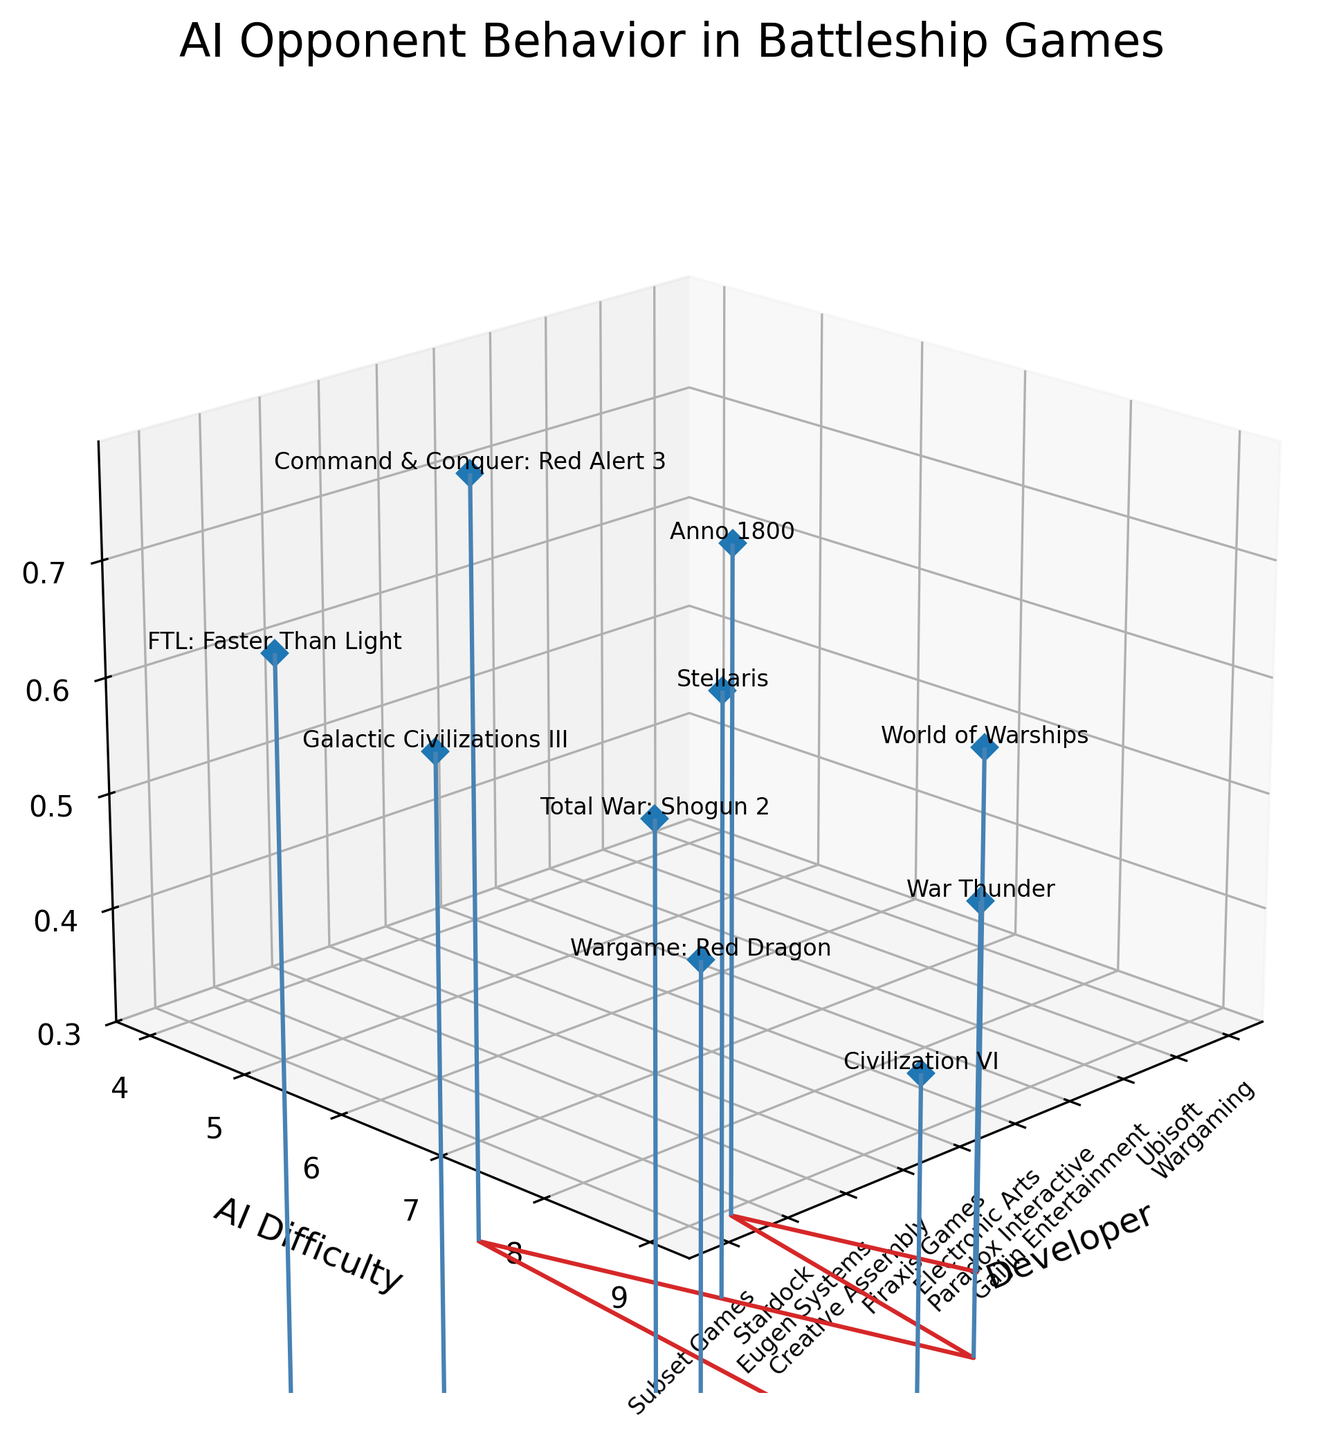What is the AI difficulty level for "War Thunder"? Look at the y-coordinate (AI Difficulty) for the "War Thunder" data point.
Answer: 8 Which game developed by "Ubisoft" has the highest player win rate? Locate the game by "Ubisoft" and look at its z-coordinate (Player Win Rate). There is only one game from Ubisoft, "Anno 1800".
Answer: Anno 1800 What's the range of AI difficulty levels shown in the plot? Identify the minimum and maximum values on the y-axis labeled "AI Difficulty".
Answer: 4-9 How many developers have player win rates less than 0.5 in their games? Count the number of data points where the z-coordinate (Player Win Rate) is less than 0.5.
Answer: 3 Which game has the lowest player win rate and what's that rate? Find the data point with the smallest z-coordinate (Player Win Rate) and note the corresponding game.
Answer: Civilization VI, 0.35 Compare the player win rates for "World of Warships" and "Total War: Shogun 2." Which one is higher? Locate the z-coordinates (Player Win Rates) for both games and compare them. "World of Warships" has a win rate of 0.48, and "Total War: Shogun 2" has a win rate of 0.52.
Answer: Total War: Shogun 2 Which developer has the easiest AI based on its difficulty level, and what's their player win rate? Find the data point with the lowest y-coordinate (AI Difficulty) and note the corresponding developer and z-coordinate (Player Win Rate).
Answer: Electronic Arts, 0.70 What's the average AI difficulty across all games? Add all y-values (AI Difficulty) and divide by the number of data points (10). (7+5+8+6+4+9+7+8+6+5)/10 = 6.5
Answer: 6.5 Rank the games by "Player Win Rate" from highest to lowest. Sort the z-coordinates (Player Win Rates) in descending order and list the corresponding games. FTL: Faster Than Light, Command & Conquer: Red Alert 3, Anno 1800, Galactic Civilizations III, Stellaris, Total War: Shogun 2, World of Warships, Wargame: Red Dragon, War Thunder, Civilization VI.
Answer: FTL: Faster Than Light > Command & Conquer: Red Alert 3 > Anno 1800 > Galactic Civilizations III > Stellaris > Total War: Shogun 2 > World of Warships > Wargame: Red Dragon > War Thunder > Civilization VI 